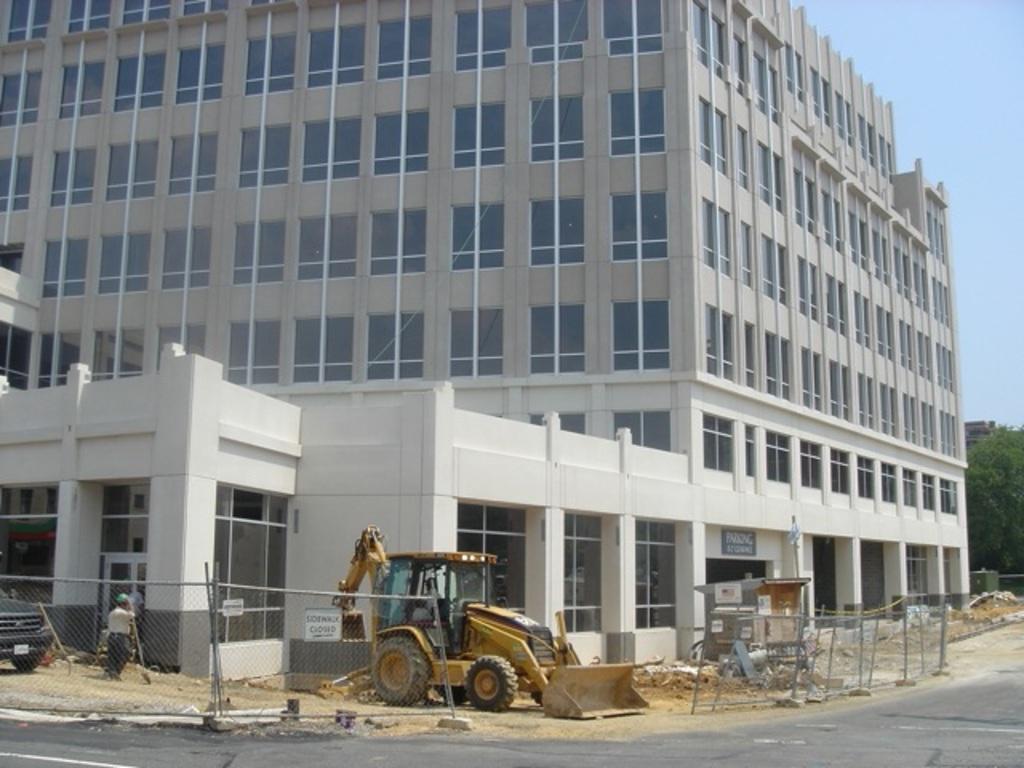Can you describe this image briefly? This picture is clicked outside. In the center we can see a vehicle and we can see the group of people and we can see the metal rods and many other objects are lying on the ground. In the left corner we can see a vehicle. In the background we can see the buildings, trees and the sky and we can see some other items. 